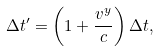<formula> <loc_0><loc_0><loc_500><loc_500>\Delta t ^ { \prime } = \left ( 1 + \frac { v ^ { y } } { c } \right ) \Delta t ,</formula> 